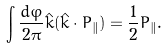<formula> <loc_0><loc_0><loc_500><loc_500>\int \frac { d \varphi } { 2 \pi } \hat { k } ( \hat { k } \cdot { P } _ { \| } ) = \frac { 1 } { 2 } { P } _ { \| } .</formula> 